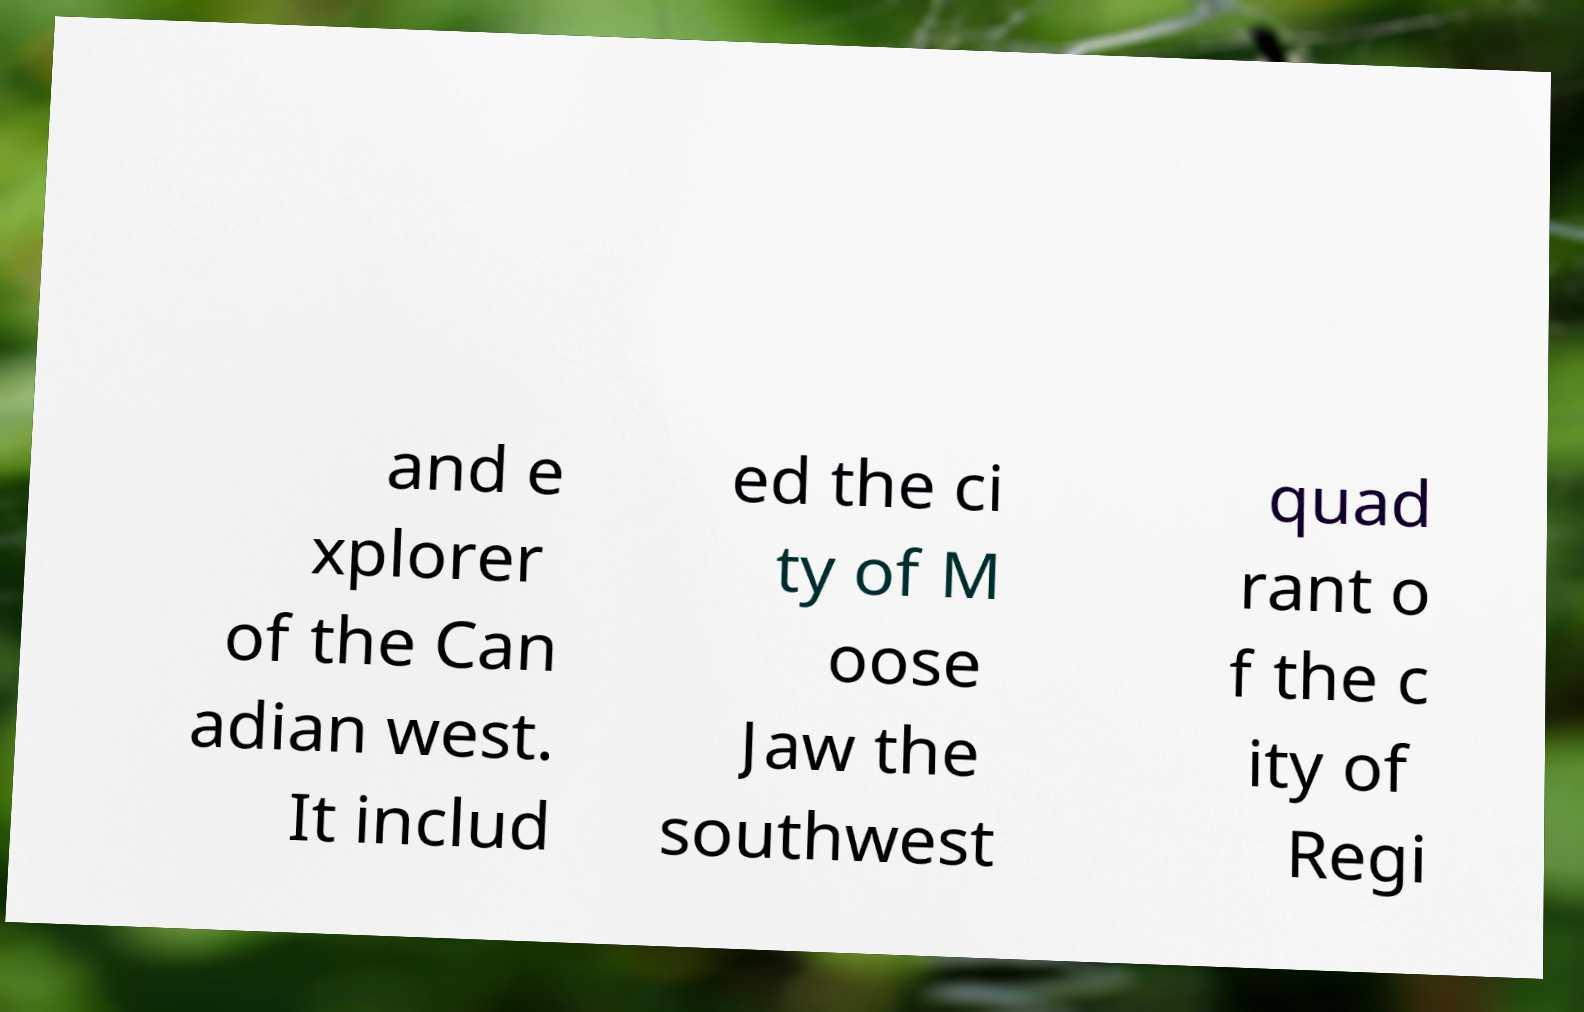What messages or text are displayed in this image? I need them in a readable, typed format. and e xplorer of the Can adian west. It includ ed the ci ty of M oose Jaw the southwest quad rant o f the c ity of Regi 